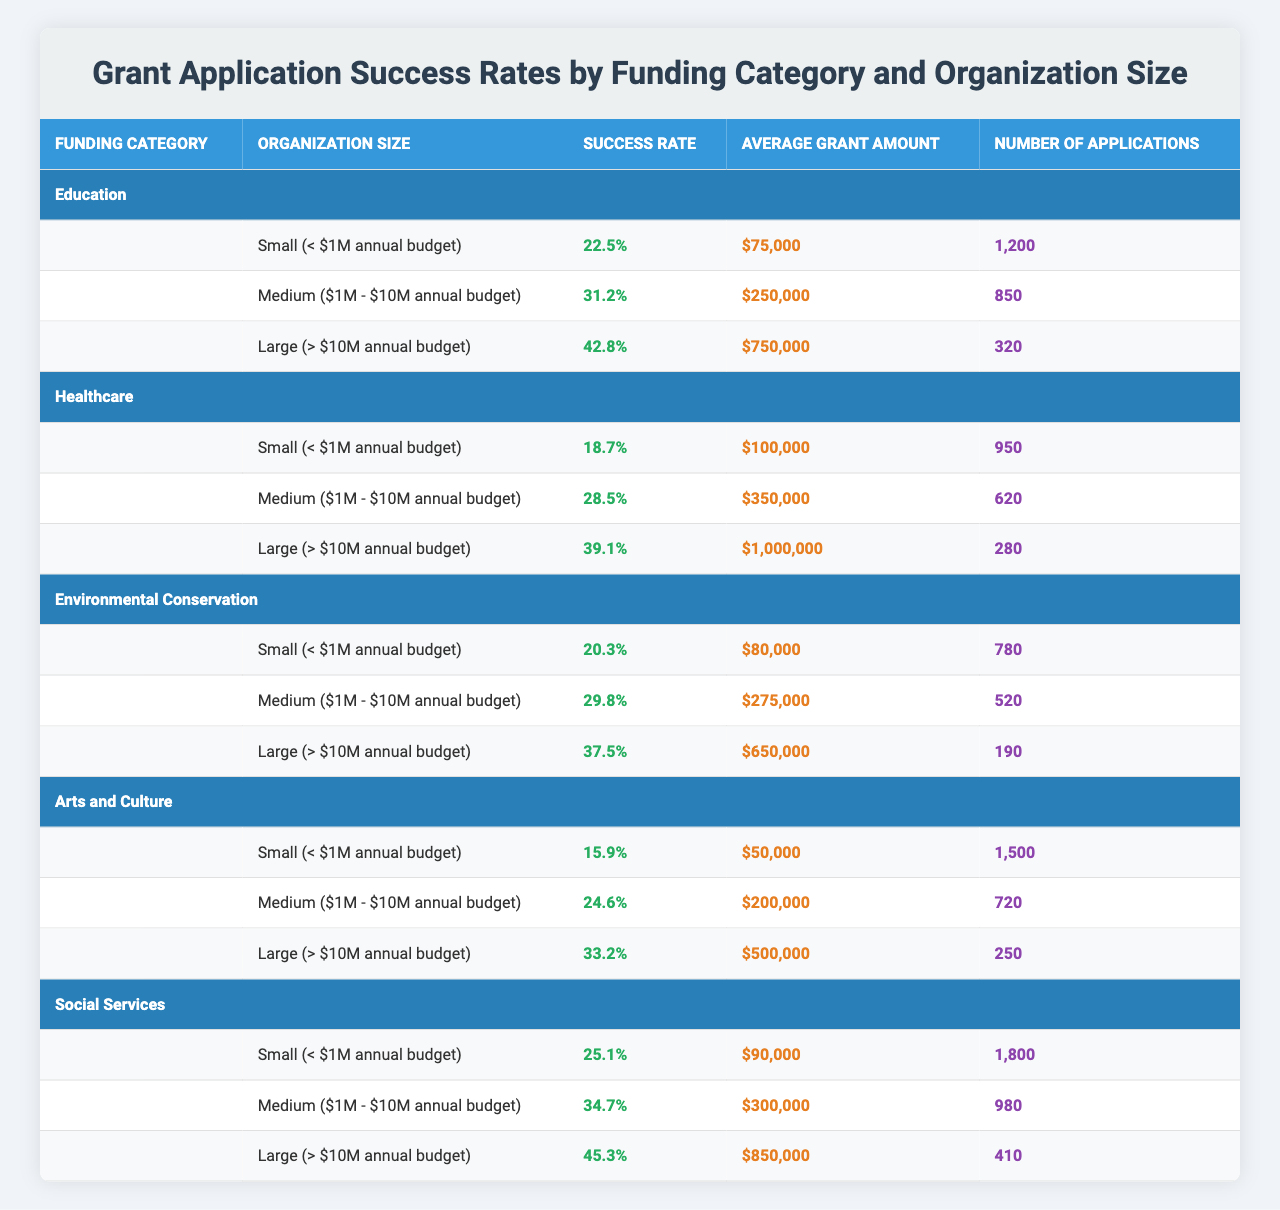What is the success rate for small organizations in the Education category? The success rate for small organizations under the Education category is listed in the table as 22.5%.
Answer: 22.5% Which funding category has the highest success rate for large organizations? The success rates for large organizations are: Education (42.8%), Healthcare (39.1%), Environmental Conservation (37.5%), Arts and Culture (33.2%), and Social Services (45.3%). The highest is Social Services at 45.3%.
Answer: Social Services What is the average grant amount for medium-sized organizations in Healthcare? The table lists the average grant amount for medium organizations in Healthcare as $350,000.
Answer: $350,000 How many applications were submitted by small organizations in the Arts and Culture category? The number of applications for small organizations in the Arts and Culture category is shown in the table as 1,500.
Answer: 1,500 What is the average success rate for all organization sizes in the Environmental Conservation category? The success rates for Environmental Conservation are 20.3% (Small), 29.8% (Medium), and 37.5% (Large). The average is calculated as (20.3 + 29.8 + 37.5) / 3 = 29.5%.
Answer: 29.5% Do medium-sized organizations in Social Services have a higher success rate than small organizations in Healthcare? The success rate for medium-sized organizations in Social Services is 34.7%, while for small organizations in Healthcare it is 18.7%. Since 34.7% is greater than 18.7%, the statement is true.
Answer: Yes Which organization size has the lowest success rate across all funding categories? The lowest success rate listed in the table is for small organizations in the Arts and Culture category at 15.9%.
Answer: Small organizations in Arts and Culture (15.9%) What is the difference in the number of applications submitted by small organizations in Social Services and small organizations in Environmental Conservation? The number of applications for small organizations in Social Services is 1,800, and for Environmental Conservation, it is 780. The difference is calculated as 1,800 - 780 = 1,020.
Answer: 1,020 Is the average grant amount for large organizations in Healthcare more than $900,000? The average grant amount for large organizations in Healthcare is $1,000,000 according to the table. Since $1,000,000 is greater than $900,000, the answer is yes.
Answer: Yes Which funding category has the highest total number of applications across all organization sizes? Adding applications for each funding category: Education (1200 + 850 + 320), Healthcare (950 + 620 + 280), Environmental Conservation (780 + 520 + 190), Arts and Culture (1500 + 720 + 250), and Social Services (1800 + 980 + 410). The totals are Education (2370), Healthcare (1850), Environmental Conservation (1490), Arts and Culture (2470), and Social Services (3190). The highest is Social Services with 3,190 applications.
Answer: Social Services 